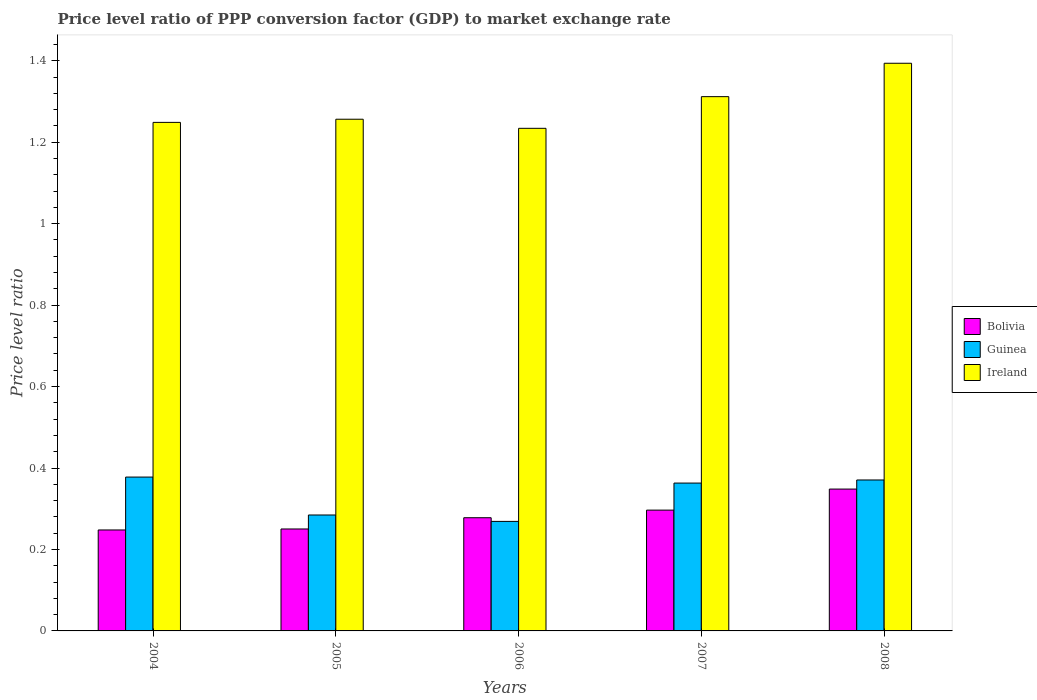How many groups of bars are there?
Make the answer very short. 5. Are the number of bars per tick equal to the number of legend labels?
Ensure brevity in your answer.  Yes. Are the number of bars on each tick of the X-axis equal?
Offer a very short reply. Yes. How many bars are there on the 1st tick from the left?
Provide a succinct answer. 3. How many bars are there on the 3rd tick from the right?
Your response must be concise. 3. What is the label of the 2nd group of bars from the left?
Give a very brief answer. 2005. In how many cases, is the number of bars for a given year not equal to the number of legend labels?
Your answer should be very brief. 0. What is the price level ratio in Guinea in 2008?
Provide a succinct answer. 0.37. Across all years, what is the maximum price level ratio in Guinea?
Ensure brevity in your answer.  0.38. Across all years, what is the minimum price level ratio in Bolivia?
Provide a short and direct response. 0.25. In which year was the price level ratio in Ireland minimum?
Provide a succinct answer. 2006. What is the total price level ratio in Guinea in the graph?
Offer a terse response. 1.66. What is the difference between the price level ratio in Guinea in 2004 and that in 2006?
Keep it short and to the point. 0.11. What is the difference between the price level ratio in Ireland in 2007 and the price level ratio in Guinea in 2004?
Your answer should be very brief. 0.93. What is the average price level ratio in Bolivia per year?
Your answer should be very brief. 0.28. In the year 2008, what is the difference between the price level ratio in Guinea and price level ratio in Bolivia?
Provide a succinct answer. 0.02. In how many years, is the price level ratio in Guinea greater than 0.32?
Provide a short and direct response. 3. What is the ratio of the price level ratio in Guinea in 2004 to that in 2007?
Your answer should be compact. 1.04. Is the price level ratio in Guinea in 2004 less than that in 2008?
Ensure brevity in your answer.  No. Is the difference between the price level ratio in Guinea in 2005 and 2007 greater than the difference between the price level ratio in Bolivia in 2005 and 2007?
Offer a very short reply. No. What is the difference between the highest and the second highest price level ratio in Bolivia?
Make the answer very short. 0.05. What is the difference between the highest and the lowest price level ratio in Bolivia?
Provide a short and direct response. 0.1. Is the sum of the price level ratio in Ireland in 2004 and 2005 greater than the maximum price level ratio in Bolivia across all years?
Offer a terse response. Yes. What does the 2nd bar from the left in 2006 represents?
Give a very brief answer. Guinea. What does the 3rd bar from the right in 2004 represents?
Provide a short and direct response. Bolivia. How many years are there in the graph?
Ensure brevity in your answer.  5. What is the difference between two consecutive major ticks on the Y-axis?
Provide a succinct answer. 0.2. How are the legend labels stacked?
Provide a short and direct response. Vertical. What is the title of the graph?
Provide a short and direct response. Price level ratio of PPP conversion factor (GDP) to market exchange rate. What is the label or title of the X-axis?
Ensure brevity in your answer.  Years. What is the label or title of the Y-axis?
Your response must be concise. Price level ratio. What is the Price level ratio in Bolivia in 2004?
Provide a short and direct response. 0.25. What is the Price level ratio in Guinea in 2004?
Provide a short and direct response. 0.38. What is the Price level ratio in Ireland in 2004?
Offer a terse response. 1.25. What is the Price level ratio in Bolivia in 2005?
Keep it short and to the point. 0.25. What is the Price level ratio in Guinea in 2005?
Your response must be concise. 0.28. What is the Price level ratio in Ireland in 2005?
Keep it short and to the point. 1.26. What is the Price level ratio of Bolivia in 2006?
Give a very brief answer. 0.28. What is the Price level ratio in Guinea in 2006?
Offer a very short reply. 0.27. What is the Price level ratio of Ireland in 2006?
Your response must be concise. 1.23. What is the Price level ratio in Bolivia in 2007?
Keep it short and to the point. 0.3. What is the Price level ratio of Guinea in 2007?
Your answer should be compact. 0.36. What is the Price level ratio of Ireland in 2007?
Keep it short and to the point. 1.31. What is the Price level ratio of Bolivia in 2008?
Ensure brevity in your answer.  0.35. What is the Price level ratio in Guinea in 2008?
Ensure brevity in your answer.  0.37. What is the Price level ratio of Ireland in 2008?
Provide a succinct answer. 1.39. Across all years, what is the maximum Price level ratio of Bolivia?
Provide a short and direct response. 0.35. Across all years, what is the maximum Price level ratio in Guinea?
Ensure brevity in your answer.  0.38. Across all years, what is the maximum Price level ratio in Ireland?
Make the answer very short. 1.39. Across all years, what is the minimum Price level ratio in Bolivia?
Provide a succinct answer. 0.25. Across all years, what is the minimum Price level ratio of Guinea?
Make the answer very short. 0.27. Across all years, what is the minimum Price level ratio in Ireland?
Provide a short and direct response. 1.23. What is the total Price level ratio of Bolivia in the graph?
Give a very brief answer. 1.42. What is the total Price level ratio of Guinea in the graph?
Give a very brief answer. 1.67. What is the total Price level ratio in Ireland in the graph?
Provide a short and direct response. 6.44. What is the difference between the Price level ratio of Bolivia in 2004 and that in 2005?
Your answer should be compact. -0. What is the difference between the Price level ratio of Guinea in 2004 and that in 2005?
Offer a very short reply. 0.09. What is the difference between the Price level ratio of Ireland in 2004 and that in 2005?
Offer a very short reply. -0.01. What is the difference between the Price level ratio in Bolivia in 2004 and that in 2006?
Provide a short and direct response. -0.03. What is the difference between the Price level ratio in Guinea in 2004 and that in 2006?
Provide a short and direct response. 0.11. What is the difference between the Price level ratio in Ireland in 2004 and that in 2006?
Give a very brief answer. 0.01. What is the difference between the Price level ratio in Bolivia in 2004 and that in 2007?
Make the answer very short. -0.05. What is the difference between the Price level ratio of Guinea in 2004 and that in 2007?
Give a very brief answer. 0.01. What is the difference between the Price level ratio of Ireland in 2004 and that in 2007?
Give a very brief answer. -0.06. What is the difference between the Price level ratio in Bolivia in 2004 and that in 2008?
Keep it short and to the point. -0.1. What is the difference between the Price level ratio of Guinea in 2004 and that in 2008?
Give a very brief answer. 0.01. What is the difference between the Price level ratio of Ireland in 2004 and that in 2008?
Provide a succinct answer. -0.15. What is the difference between the Price level ratio of Bolivia in 2005 and that in 2006?
Your answer should be compact. -0.03. What is the difference between the Price level ratio in Guinea in 2005 and that in 2006?
Ensure brevity in your answer.  0.02. What is the difference between the Price level ratio of Ireland in 2005 and that in 2006?
Your answer should be compact. 0.02. What is the difference between the Price level ratio in Bolivia in 2005 and that in 2007?
Give a very brief answer. -0.05. What is the difference between the Price level ratio in Guinea in 2005 and that in 2007?
Provide a short and direct response. -0.08. What is the difference between the Price level ratio in Ireland in 2005 and that in 2007?
Offer a terse response. -0.06. What is the difference between the Price level ratio in Bolivia in 2005 and that in 2008?
Your answer should be very brief. -0.1. What is the difference between the Price level ratio in Guinea in 2005 and that in 2008?
Provide a short and direct response. -0.09. What is the difference between the Price level ratio of Ireland in 2005 and that in 2008?
Offer a terse response. -0.14. What is the difference between the Price level ratio of Bolivia in 2006 and that in 2007?
Provide a succinct answer. -0.02. What is the difference between the Price level ratio in Guinea in 2006 and that in 2007?
Ensure brevity in your answer.  -0.09. What is the difference between the Price level ratio of Ireland in 2006 and that in 2007?
Keep it short and to the point. -0.08. What is the difference between the Price level ratio of Bolivia in 2006 and that in 2008?
Keep it short and to the point. -0.07. What is the difference between the Price level ratio in Guinea in 2006 and that in 2008?
Your response must be concise. -0.1. What is the difference between the Price level ratio in Ireland in 2006 and that in 2008?
Your answer should be compact. -0.16. What is the difference between the Price level ratio of Bolivia in 2007 and that in 2008?
Your answer should be very brief. -0.05. What is the difference between the Price level ratio of Guinea in 2007 and that in 2008?
Your answer should be compact. -0.01. What is the difference between the Price level ratio of Ireland in 2007 and that in 2008?
Your answer should be very brief. -0.08. What is the difference between the Price level ratio of Bolivia in 2004 and the Price level ratio of Guinea in 2005?
Your answer should be very brief. -0.04. What is the difference between the Price level ratio in Bolivia in 2004 and the Price level ratio in Ireland in 2005?
Your answer should be compact. -1.01. What is the difference between the Price level ratio of Guinea in 2004 and the Price level ratio of Ireland in 2005?
Give a very brief answer. -0.88. What is the difference between the Price level ratio in Bolivia in 2004 and the Price level ratio in Guinea in 2006?
Provide a succinct answer. -0.02. What is the difference between the Price level ratio of Bolivia in 2004 and the Price level ratio of Ireland in 2006?
Ensure brevity in your answer.  -0.99. What is the difference between the Price level ratio in Guinea in 2004 and the Price level ratio in Ireland in 2006?
Your answer should be very brief. -0.86. What is the difference between the Price level ratio of Bolivia in 2004 and the Price level ratio of Guinea in 2007?
Your response must be concise. -0.12. What is the difference between the Price level ratio in Bolivia in 2004 and the Price level ratio in Ireland in 2007?
Your response must be concise. -1.06. What is the difference between the Price level ratio in Guinea in 2004 and the Price level ratio in Ireland in 2007?
Your answer should be compact. -0.93. What is the difference between the Price level ratio in Bolivia in 2004 and the Price level ratio in Guinea in 2008?
Provide a succinct answer. -0.12. What is the difference between the Price level ratio in Bolivia in 2004 and the Price level ratio in Ireland in 2008?
Offer a terse response. -1.15. What is the difference between the Price level ratio of Guinea in 2004 and the Price level ratio of Ireland in 2008?
Your answer should be very brief. -1.02. What is the difference between the Price level ratio of Bolivia in 2005 and the Price level ratio of Guinea in 2006?
Give a very brief answer. -0.02. What is the difference between the Price level ratio of Bolivia in 2005 and the Price level ratio of Ireland in 2006?
Offer a terse response. -0.98. What is the difference between the Price level ratio in Guinea in 2005 and the Price level ratio in Ireland in 2006?
Make the answer very short. -0.95. What is the difference between the Price level ratio in Bolivia in 2005 and the Price level ratio in Guinea in 2007?
Offer a very short reply. -0.11. What is the difference between the Price level ratio of Bolivia in 2005 and the Price level ratio of Ireland in 2007?
Your response must be concise. -1.06. What is the difference between the Price level ratio of Guinea in 2005 and the Price level ratio of Ireland in 2007?
Offer a very short reply. -1.03. What is the difference between the Price level ratio of Bolivia in 2005 and the Price level ratio of Guinea in 2008?
Offer a terse response. -0.12. What is the difference between the Price level ratio in Bolivia in 2005 and the Price level ratio in Ireland in 2008?
Your response must be concise. -1.14. What is the difference between the Price level ratio in Guinea in 2005 and the Price level ratio in Ireland in 2008?
Offer a very short reply. -1.11. What is the difference between the Price level ratio in Bolivia in 2006 and the Price level ratio in Guinea in 2007?
Make the answer very short. -0.09. What is the difference between the Price level ratio of Bolivia in 2006 and the Price level ratio of Ireland in 2007?
Your answer should be very brief. -1.03. What is the difference between the Price level ratio in Guinea in 2006 and the Price level ratio in Ireland in 2007?
Provide a succinct answer. -1.04. What is the difference between the Price level ratio of Bolivia in 2006 and the Price level ratio of Guinea in 2008?
Make the answer very short. -0.09. What is the difference between the Price level ratio in Bolivia in 2006 and the Price level ratio in Ireland in 2008?
Your answer should be very brief. -1.12. What is the difference between the Price level ratio in Guinea in 2006 and the Price level ratio in Ireland in 2008?
Offer a very short reply. -1.12. What is the difference between the Price level ratio of Bolivia in 2007 and the Price level ratio of Guinea in 2008?
Offer a terse response. -0.07. What is the difference between the Price level ratio of Bolivia in 2007 and the Price level ratio of Ireland in 2008?
Give a very brief answer. -1.1. What is the difference between the Price level ratio of Guinea in 2007 and the Price level ratio of Ireland in 2008?
Give a very brief answer. -1.03. What is the average Price level ratio of Bolivia per year?
Offer a terse response. 0.28. What is the average Price level ratio in Guinea per year?
Provide a succinct answer. 0.33. What is the average Price level ratio in Ireland per year?
Offer a very short reply. 1.29. In the year 2004, what is the difference between the Price level ratio in Bolivia and Price level ratio in Guinea?
Ensure brevity in your answer.  -0.13. In the year 2004, what is the difference between the Price level ratio of Bolivia and Price level ratio of Ireland?
Give a very brief answer. -1. In the year 2004, what is the difference between the Price level ratio of Guinea and Price level ratio of Ireland?
Offer a terse response. -0.87. In the year 2005, what is the difference between the Price level ratio of Bolivia and Price level ratio of Guinea?
Provide a succinct answer. -0.03. In the year 2005, what is the difference between the Price level ratio in Bolivia and Price level ratio in Ireland?
Provide a short and direct response. -1.01. In the year 2005, what is the difference between the Price level ratio in Guinea and Price level ratio in Ireland?
Offer a very short reply. -0.97. In the year 2006, what is the difference between the Price level ratio of Bolivia and Price level ratio of Guinea?
Offer a very short reply. 0.01. In the year 2006, what is the difference between the Price level ratio in Bolivia and Price level ratio in Ireland?
Give a very brief answer. -0.96. In the year 2006, what is the difference between the Price level ratio of Guinea and Price level ratio of Ireland?
Ensure brevity in your answer.  -0.97. In the year 2007, what is the difference between the Price level ratio in Bolivia and Price level ratio in Guinea?
Your answer should be very brief. -0.07. In the year 2007, what is the difference between the Price level ratio of Bolivia and Price level ratio of Ireland?
Give a very brief answer. -1.02. In the year 2007, what is the difference between the Price level ratio in Guinea and Price level ratio in Ireland?
Offer a terse response. -0.95. In the year 2008, what is the difference between the Price level ratio of Bolivia and Price level ratio of Guinea?
Keep it short and to the point. -0.02. In the year 2008, what is the difference between the Price level ratio of Bolivia and Price level ratio of Ireland?
Provide a succinct answer. -1.05. In the year 2008, what is the difference between the Price level ratio in Guinea and Price level ratio in Ireland?
Keep it short and to the point. -1.02. What is the ratio of the Price level ratio in Bolivia in 2004 to that in 2005?
Your response must be concise. 0.99. What is the ratio of the Price level ratio of Guinea in 2004 to that in 2005?
Keep it short and to the point. 1.33. What is the ratio of the Price level ratio in Bolivia in 2004 to that in 2006?
Provide a succinct answer. 0.89. What is the ratio of the Price level ratio of Guinea in 2004 to that in 2006?
Keep it short and to the point. 1.4. What is the ratio of the Price level ratio in Ireland in 2004 to that in 2006?
Offer a terse response. 1.01. What is the ratio of the Price level ratio in Bolivia in 2004 to that in 2007?
Offer a very short reply. 0.84. What is the ratio of the Price level ratio in Guinea in 2004 to that in 2007?
Give a very brief answer. 1.04. What is the ratio of the Price level ratio of Ireland in 2004 to that in 2007?
Give a very brief answer. 0.95. What is the ratio of the Price level ratio in Bolivia in 2004 to that in 2008?
Make the answer very short. 0.71. What is the ratio of the Price level ratio in Guinea in 2004 to that in 2008?
Provide a succinct answer. 1.02. What is the ratio of the Price level ratio in Ireland in 2004 to that in 2008?
Provide a succinct answer. 0.9. What is the ratio of the Price level ratio in Bolivia in 2005 to that in 2006?
Offer a very short reply. 0.9. What is the ratio of the Price level ratio of Guinea in 2005 to that in 2006?
Make the answer very short. 1.06. What is the ratio of the Price level ratio in Ireland in 2005 to that in 2006?
Provide a short and direct response. 1.02. What is the ratio of the Price level ratio of Bolivia in 2005 to that in 2007?
Make the answer very short. 0.84. What is the ratio of the Price level ratio in Guinea in 2005 to that in 2007?
Provide a succinct answer. 0.78. What is the ratio of the Price level ratio of Ireland in 2005 to that in 2007?
Provide a short and direct response. 0.96. What is the ratio of the Price level ratio of Bolivia in 2005 to that in 2008?
Make the answer very short. 0.72. What is the ratio of the Price level ratio in Guinea in 2005 to that in 2008?
Offer a very short reply. 0.77. What is the ratio of the Price level ratio of Ireland in 2005 to that in 2008?
Give a very brief answer. 0.9. What is the ratio of the Price level ratio of Bolivia in 2006 to that in 2007?
Keep it short and to the point. 0.94. What is the ratio of the Price level ratio in Guinea in 2006 to that in 2007?
Offer a terse response. 0.74. What is the ratio of the Price level ratio in Ireland in 2006 to that in 2007?
Your response must be concise. 0.94. What is the ratio of the Price level ratio in Bolivia in 2006 to that in 2008?
Keep it short and to the point. 0.8. What is the ratio of the Price level ratio of Guinea in 2006 to that in 2008?
Make the answer very short. 0.73. What is the ratio of the Price level ratio of Ireland in 2006 to that in 2008?
Your response must be concise. 0.89. What is the ratio of the Price level ratio of Bolivia in 2007 to that in 2008?
Provide a succinct answer. 0.85. What is the ratio of the Price level ratio of Guinea in 2007 to that in 2008?
Offer a terse response. 0.98. What is the ratio of the Price level ratio in Ireland in 2007 to that in 2008?
Your answer should be compact. 0.94. What is the difference between the highest and the second highest Price level ratio of Bolivia?
Provide a succinct answer. 0.05. What is the difference between the highest and the second highest Price level ratio of Guinea?
Your response must be concise. 0.01. What is the difference between the highest and the second highest Price level ratio of Ireland?
Your answer should be very brief. 0.08. What is the difference between the highest and the lowest Price level ratio of Bolivia?
Offer a very short reply. 0.1. What is the difference between the highest and the lowest Price level ratio of Guinea?
Give a very brief answer. 0.11. What is the difference between the highest and the lowest Price level ratio of Ireland?
Your answer should be compact. 0.16. 